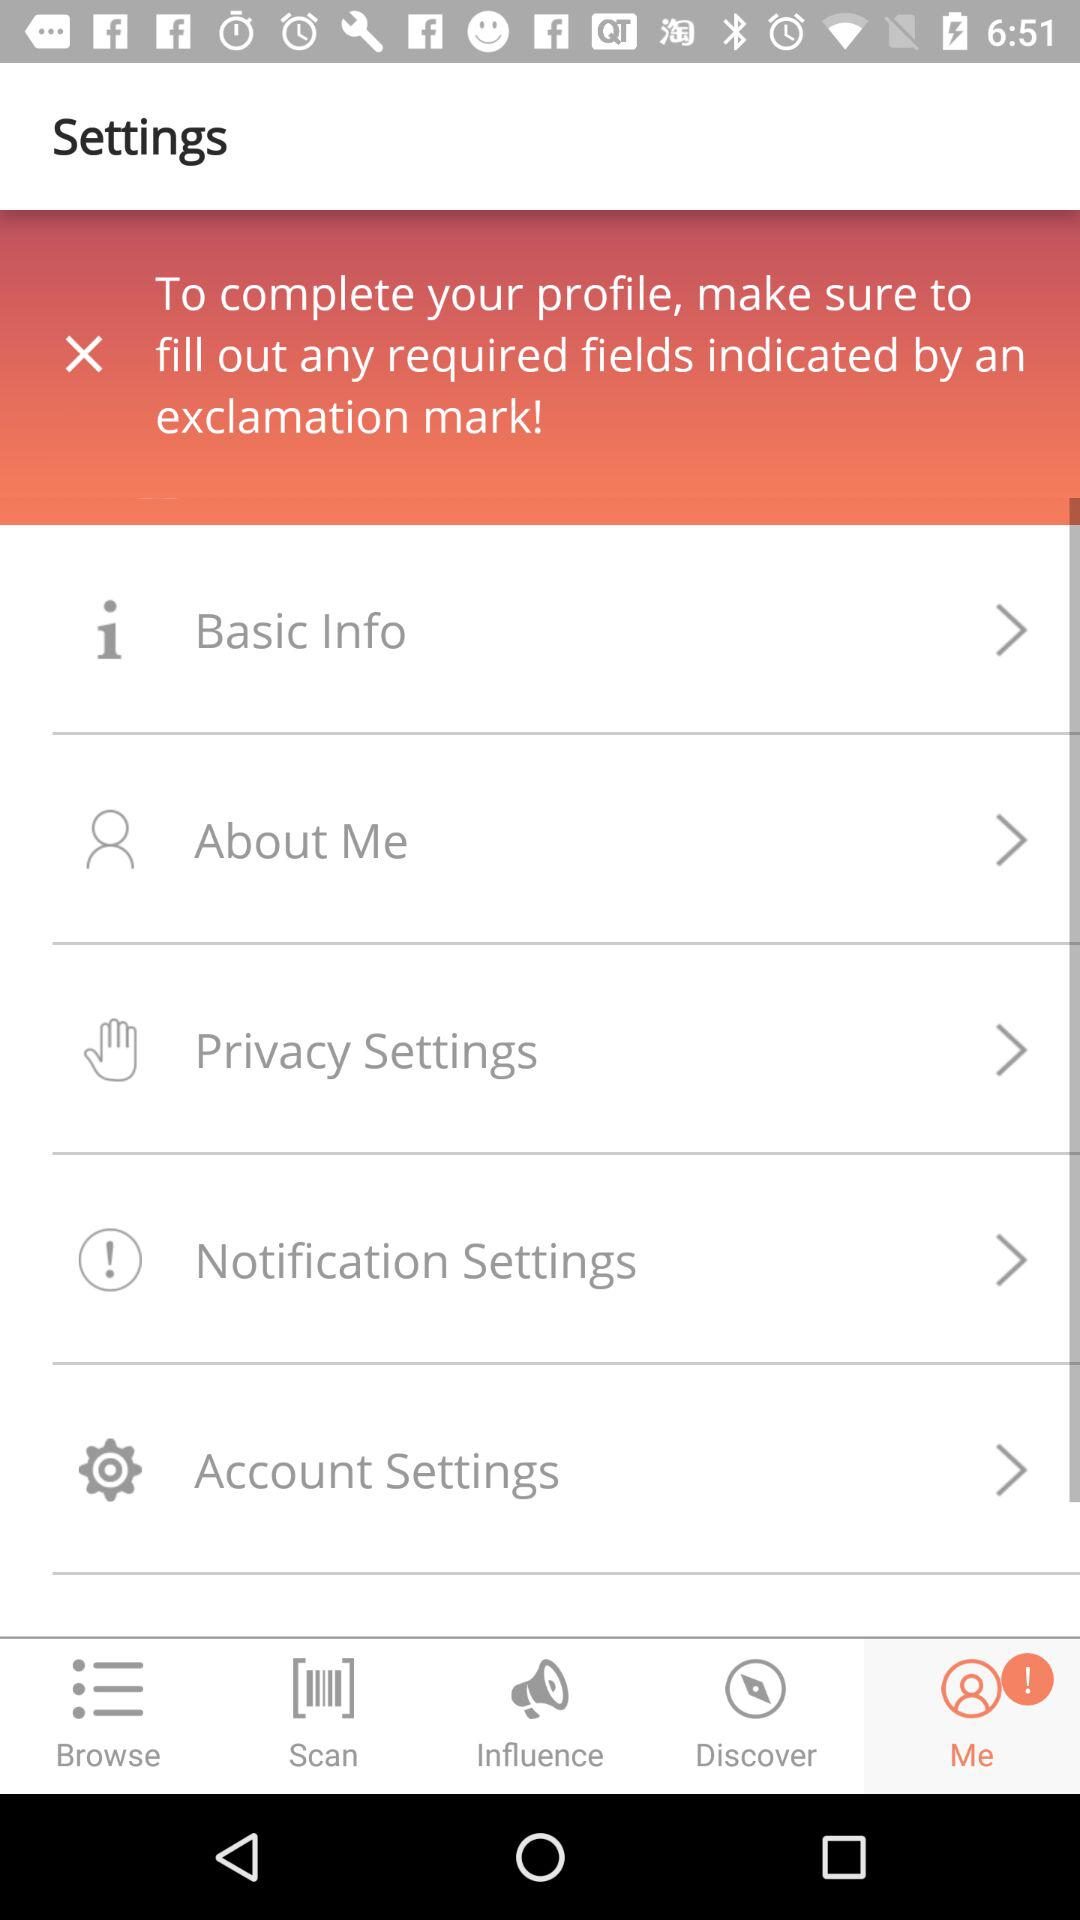Which tab is selected? The selected tab is "Me". 